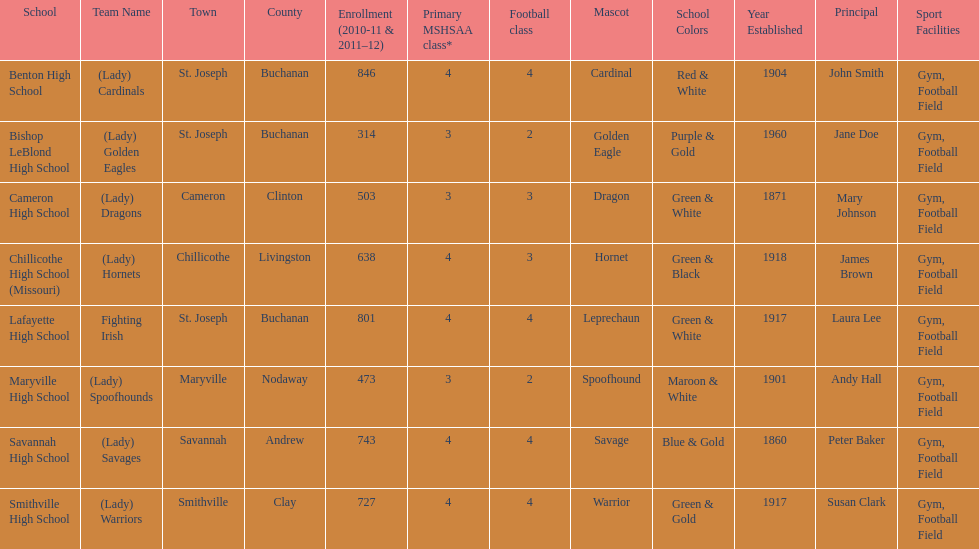Which schools are in the same town as bishop leblond? Benton High School, Lafayette High School. 